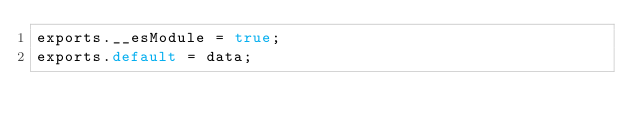Convert code to text. <code><loc_0><loc_0><loc_500><loc_500><_JavaScript_>exports.__esModule = true;
exports.default = data;
</code> 